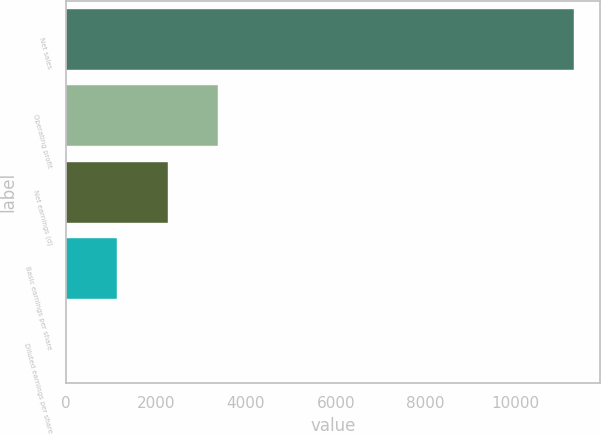Convert chart. <chart><loc_0><loc_0><loc_500><loc_500><bar_chart><fcel>Net sales<fcel>Operating profit<fcel>Net earnings (d)<fcel>Basic earnings per share<fcel>Diluted earnings per share<nl><fcel>11306<fcel>3393.72<fcel>2263.4<fcel>1133.08<fcel>2.76<nl></chart> 